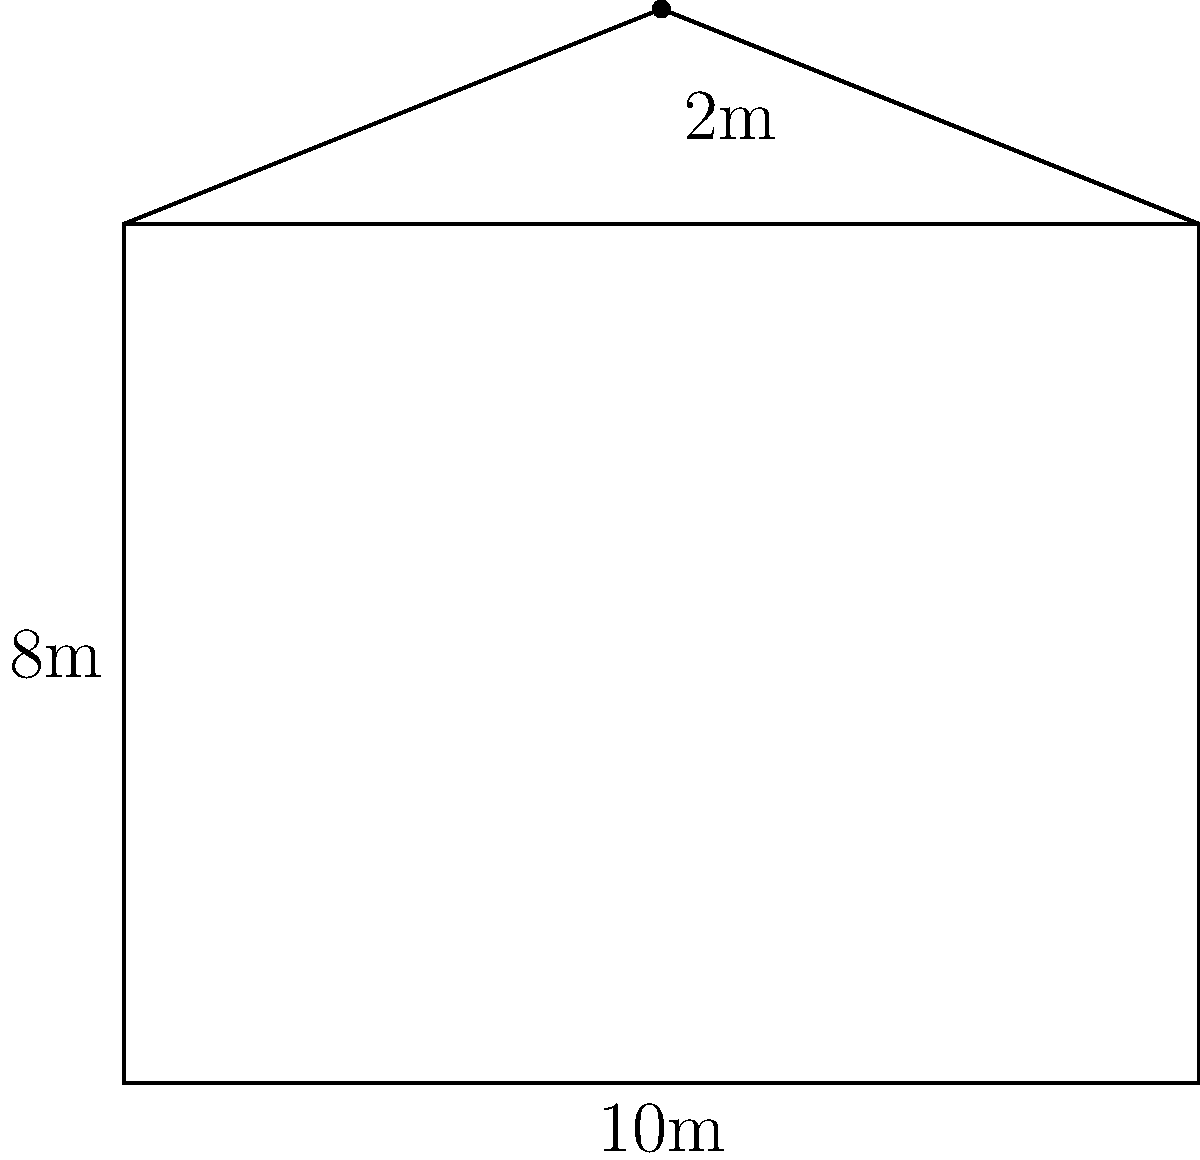Calculate the total volume of air in a house with the given floor plan dimensions. The main living area is rectangular with a length of 10m and a width of 8m, and a ceiling height of 2.5m. The attic space is triangular, with a peak height of 2m above the main ceiling. Assume the attic spans the entire length and width of the house. To calculate the total volume of air in the house, we need to find the volume of the main living area and the attic separately, then add them together.

1. Volume of main living area:
   $V_{main} = length \times width \times height$
   $V_{main} = 10m \times 8m \times 2.5m = 200m^3$

2. Volume of attic:
   The attic is a triangular prism. Its volume is calculated by multiplying the area of the triangular cross-section by the length of the house.
   
   Area of triangular cross-section:
   $A_{triangle} = \frac{1}{2} \times base \times height$
   $A_{triangle} = \frac{1}{2} \times 8m \times 2m = 8m^2$
   
   Volume of attic:
   $V_{attic} = A_{triangle} \times length$
   $V_{attic} = 8m^2 \times 10m = 80m^3$

3. Total volume:
   $V_{total} = V_{main} + V_{attic}$
   $V_{total} = 200m^3 + 80m^3 = 280m^3$

Therefore, the total volume of air in the house is 280 cubic meters.
Answer: $280m^3$ 